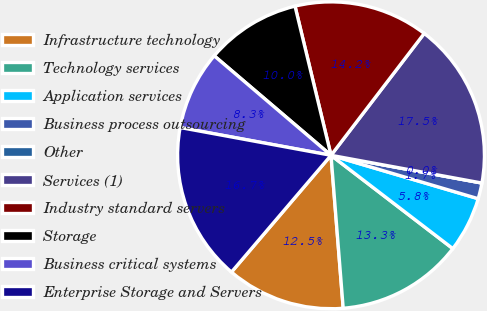<chart> <loc_0><loc_0><loc_500><loc_500><pie_chart><fcel>Infrastructure technology<fcel>Technology services<fcel>Application services<fcel>Business process outsourcing<fcel>Other<fcel>Services (1)<fcel>Industry standard servers<fcel>Storage<fcel>Business critical systems<fcel>Enterprise Storage and Servers<nl><fcel>12.5%<fcel>13.33%<fcel>5.84%<fcel>1.67%<fcel>0.0%<fcel>17.5%<fcel>14.16%<fcel>10.0%<fcel>8.33%<fcel>16.66%<nl></chart> 